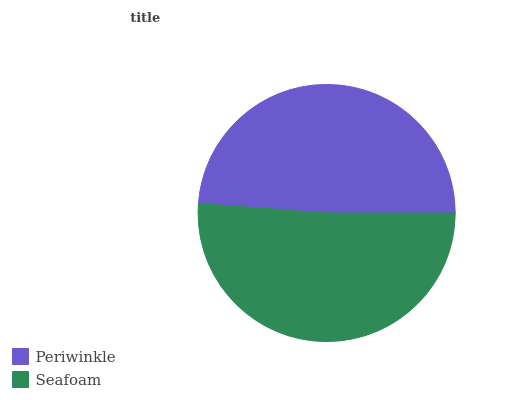Is Periwinkle the minimum?
Answer yes or no. Yes. Is Seafoam the maximum?
Answer yes or no. Yes. Is Seafoam the minimum?
Answer yes or no. No. Is Seafoam greater than Periwinkle?
Answer yes or no. Yes. Is Periwinkle less than Seafoam?
Answer yes or no. Yes. Is Periwinkle greater than Seafoam?
Answer yes or no. No. Is Seafoam less than Periwinkle?
Answer yes or no. No. Is Seafoam the high median?
Answer yes or no. Yes. Is Periwinkle the low median?
Answer yes or no. Yes. Is Periwinkle the high median?
Answer yes or no. No. Is Seafoam the low median?
Answer yes or no. No. 